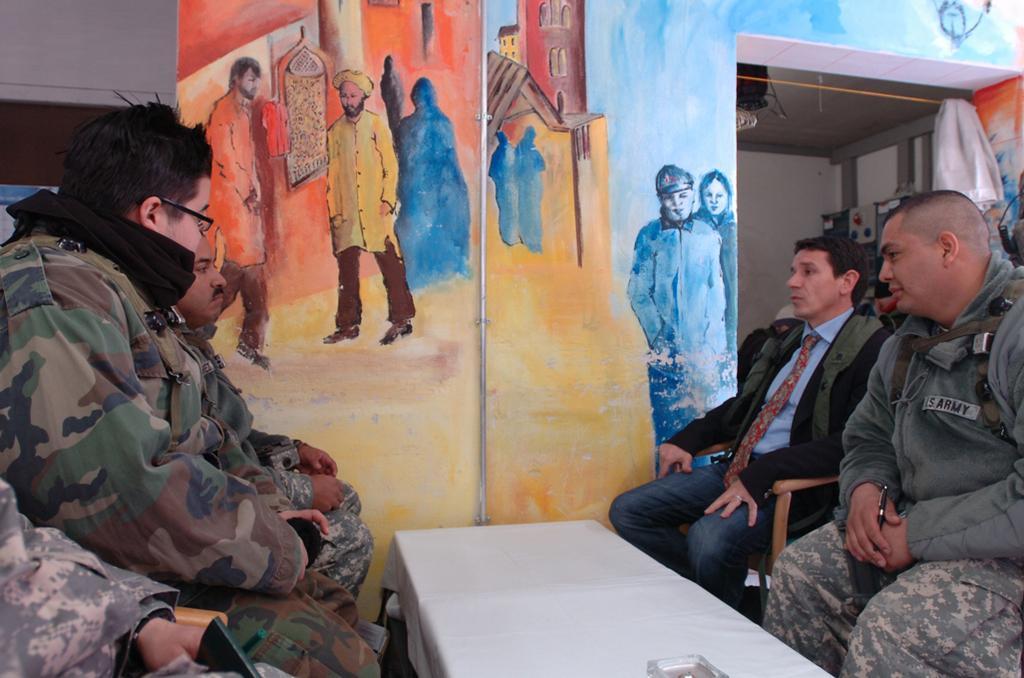Please provide a concise description of this image. This picture describes about group of people they are all seated on the chair in front of them we can see a table and we can see a wall painting here. 